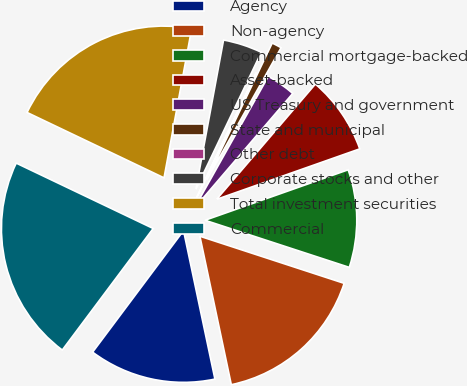Convert chart to OTSL. <chart><loc_0><loc_0><loc_500><loc_500><pie_chart><fcel>Agency<fcel>Non-agency<fcel>Commercial mortgage-backed<fcel>Asset-backed<fcel>US Treasury and government<fcel>State and municipal<fcel>Other debt<fcel>Corporate stocks and other<fcel>Total investment securities<fcel>Commercial<nl><fcel>13.54%<fcel>16.66%<fcel>10.42%<fcel>8.33%<fcel>3.13%<fcel>1.05%<fcel>0.01%<fcel>4.17%<fcel>20.83%<fcel>21.87%<nl></chart> 